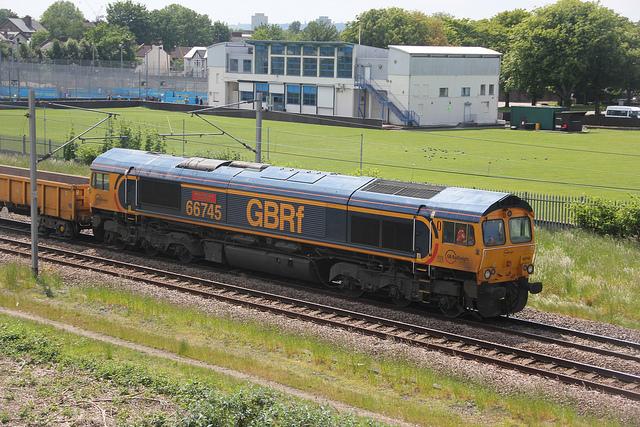What are the numbers on the side of the train?
Give a very brief answer. 66745. How many tracks on the ground?
Concise answer only. 2. What is this vehicle called?
Keep it brief. Train. 